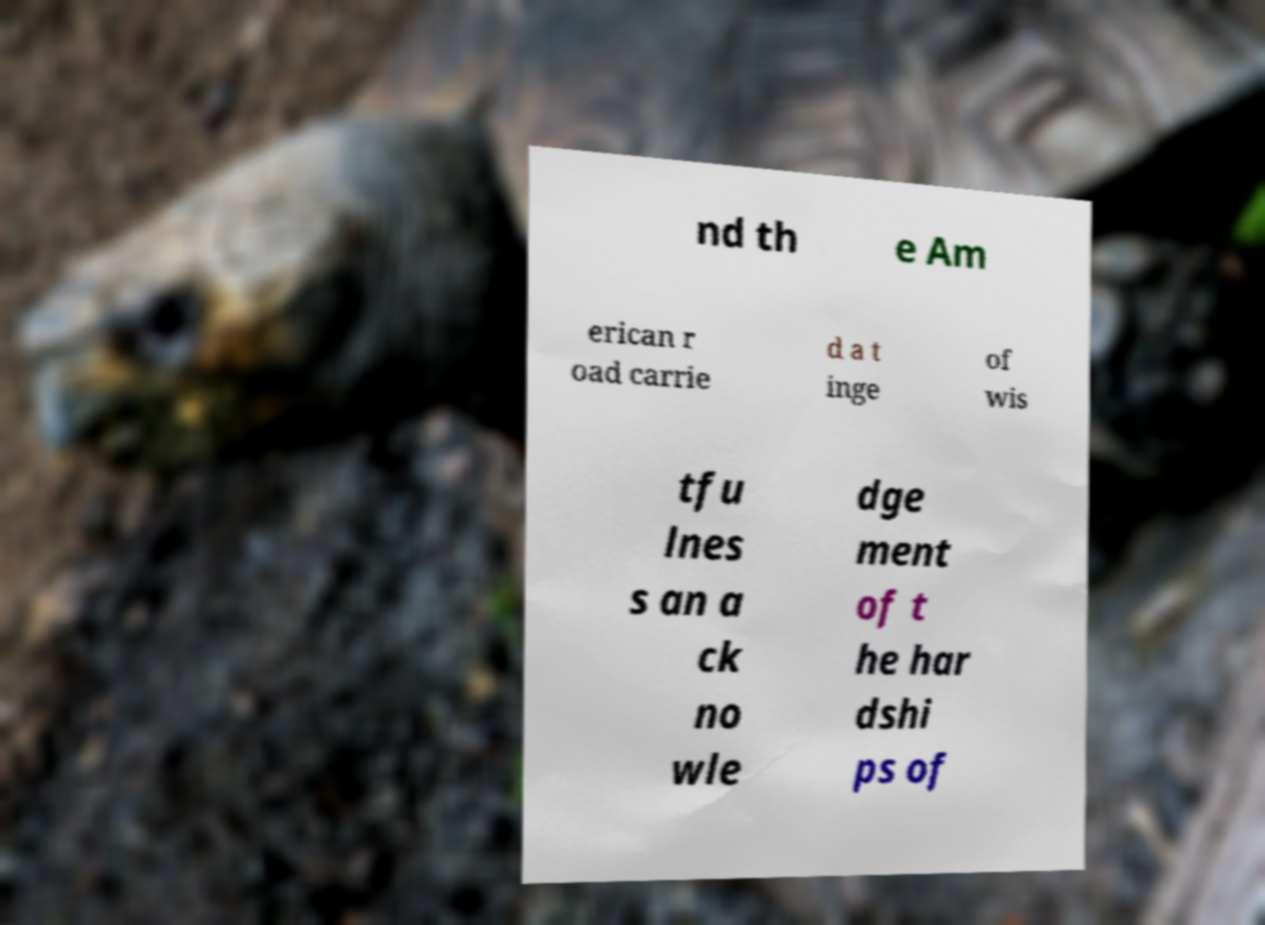I need the written content from this picture converted into text. Can you do that? nd th e Am erican r oad carrie d a t inge of wis tfu lnes s an a ck no wle dge ment of t he har dshi ps of 